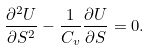Convert formula to latex. <formula><loc_0><loc_0><loc_500><loc_500>\frac { \partial ^ { 2 } U } { \partial S ^ { 2 } } - \frac { 1 } { C _ { v } } \frac { \partial U } { \partial S } = 0 .</formula> 